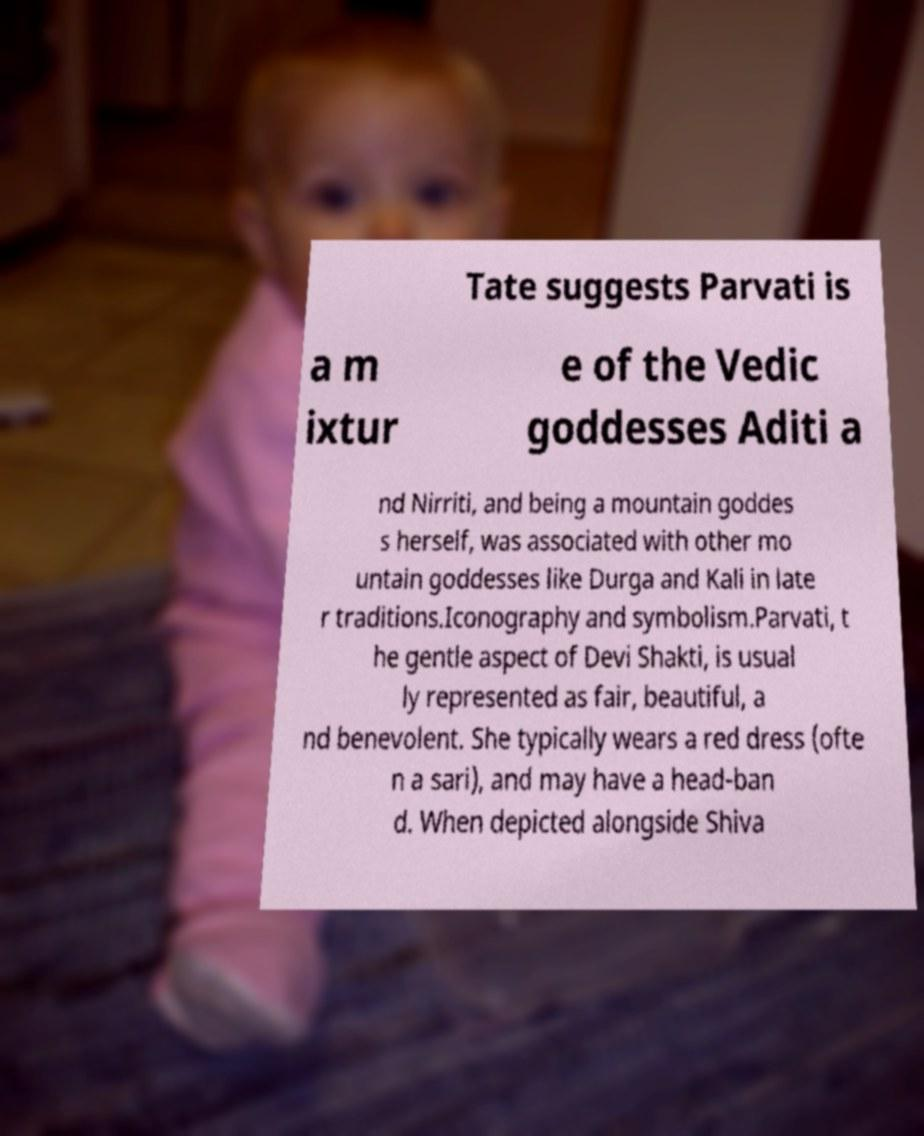I need the written content from this picture converted into text. Can you do that? Tate suggests Parvati is a m ixtur e of the Vedic goddesses Aditi a nd Nirriti, and being a mountain goddes s herself, was associated with other mo untain goddesses like Durga and Kali in late r traditions.Iconography and symbolism.Parvati, t he gentle aspect of Devi Shakti, is usual ly represented as fair, beautiful, a nd benevolent. She typically wears a red dress (ofte n a sari), and may have a head-ban d. When depicted alongside Shiva 